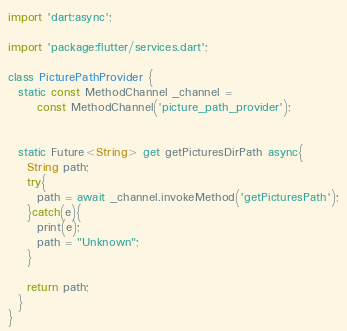<code> <loc_0><loc_0><loc_500><loc_500><_Dart_>
import 'dart:async';

import 'package:flutter/services.dart';

class PicturePathProvider {
  static const MethodChannel _channel =
      const MethodChannel('picture_path_provider');


  static Future<String> get getPicturesDirPath async{
    String path;
    try{
      path = await _channel.invokeMethod('getPicturesPath');
    }catch(e){
      print(e);
      path = "Unknown";
    }

    return path;
  }
}
</code> 